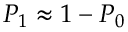<formula> <loc_0><loc_0><loc_500><loc_500>P _ { 1 } \approx 1 - P _ { 0 }</formula> 